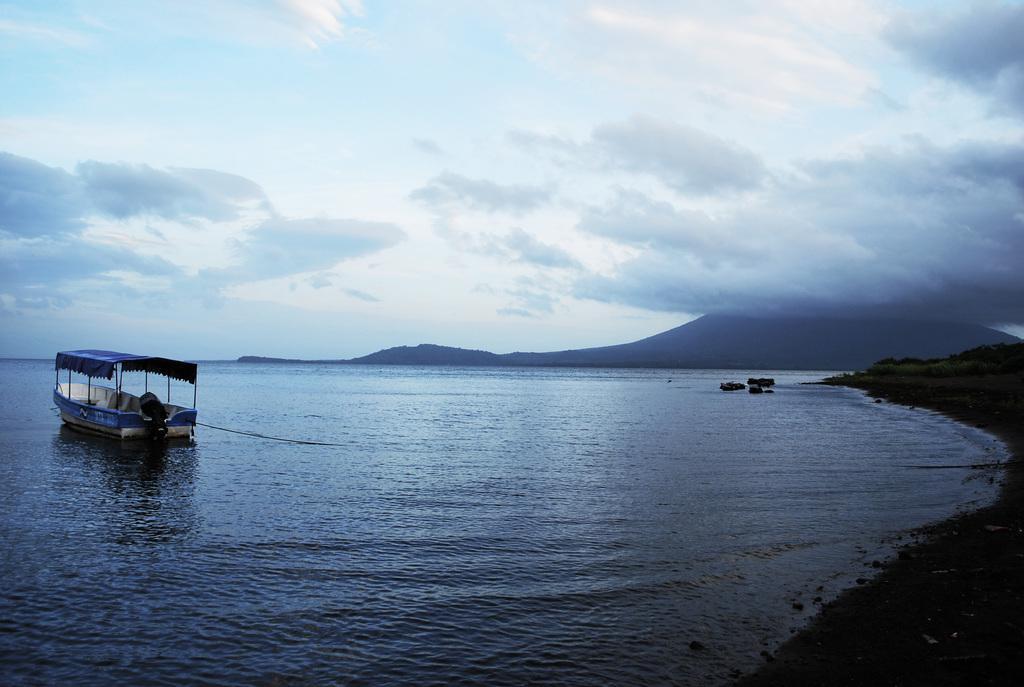In one or two sentences, can you explain what this image depicts? In this image, we can see water, there is a boat on the water, we can see the mountain, at the top there is a sky which is cloudy. 